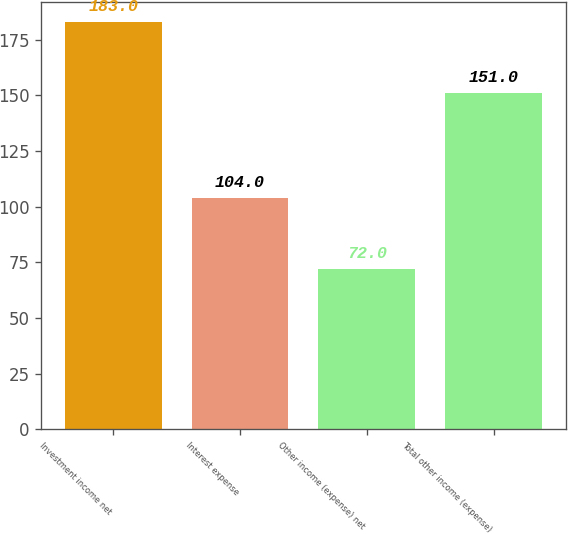Convert chart to OTSL. <chart><loc_0><loc_0><loc_500><loc_500><bar_chart><fcel>Investment income net<fcel>Interest expense<fcel>Other income (expense) net<fcel>Total other income (expense)<nl><fcel>183<fcel>104<fcel>72<fcel>151<nl></chart> 